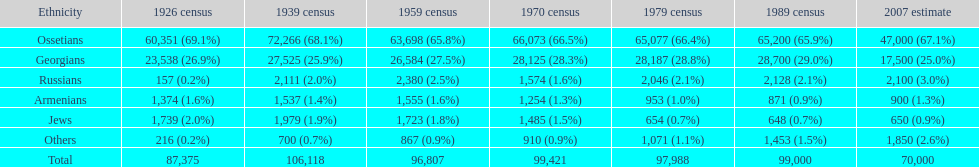What ethnic group is at the summit? Ossetians. 